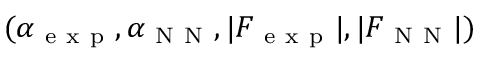Convert formula to latex. <formula><loc_0><loc_0><loc_500><loc_500>( \alpha _ { e x p } , \alpha _ { N N } , | F _ { e x p } | , | F _ { N N } | )</formula> 